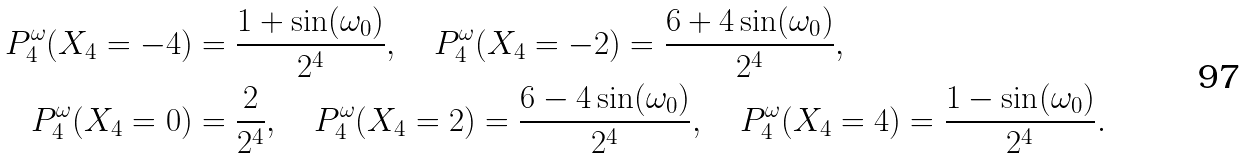<formula> <loc_0><loc_0><loc_500><loc_500>P ^ { \omega } _ { 4 } ( X _ { 4 } = - 4 ) & = \frac { 1 + \sin ( \omega _ { 0 } ) } { 2 ^ { 4 } } , \quad P ^ { \omega } _ { 4 } ( X _ { 4 } = - 2 ) = \frac { 6 + 4 \sin ( \omega _ { 0 } ) } { 2 ^ { 4 } } , \\ P ^ { \omega } _ { 4 } ( X _ { 4 } = 0 ) & = \frac { 2 } { 2 ^ { 4 } } , \quad P ^ { \omega } _ { 4 } ( X _ { 4 } = 2 ) = \frac { 6 - 4 \sin ( \omega _ { 0 } ) } { 2 ^ { 4 } } , \quad P ^ { \omega } _ { 4 } ( X _ { 4 } = 4 ) = \frac { 1 - \sin ( \omega _ { 0 } ) } { 2 ^ { 4 } } .</formula> 